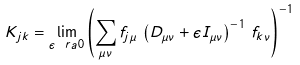Convert formula to latex. <formula><loc_0><loc_0><loc_500><loc_500>K _ { j k } = \lim _ { \epsilon \ r a 0 } \left ( \sum _ { \mu \nu } f _ { j \mu } \, \left ( D _ { \mu \nu } + \epsilon I _ { \mu \nu } \right ) ^ { - 1 } \, f _ { k \nu } \right ) ^ { - 1 }</formula> 